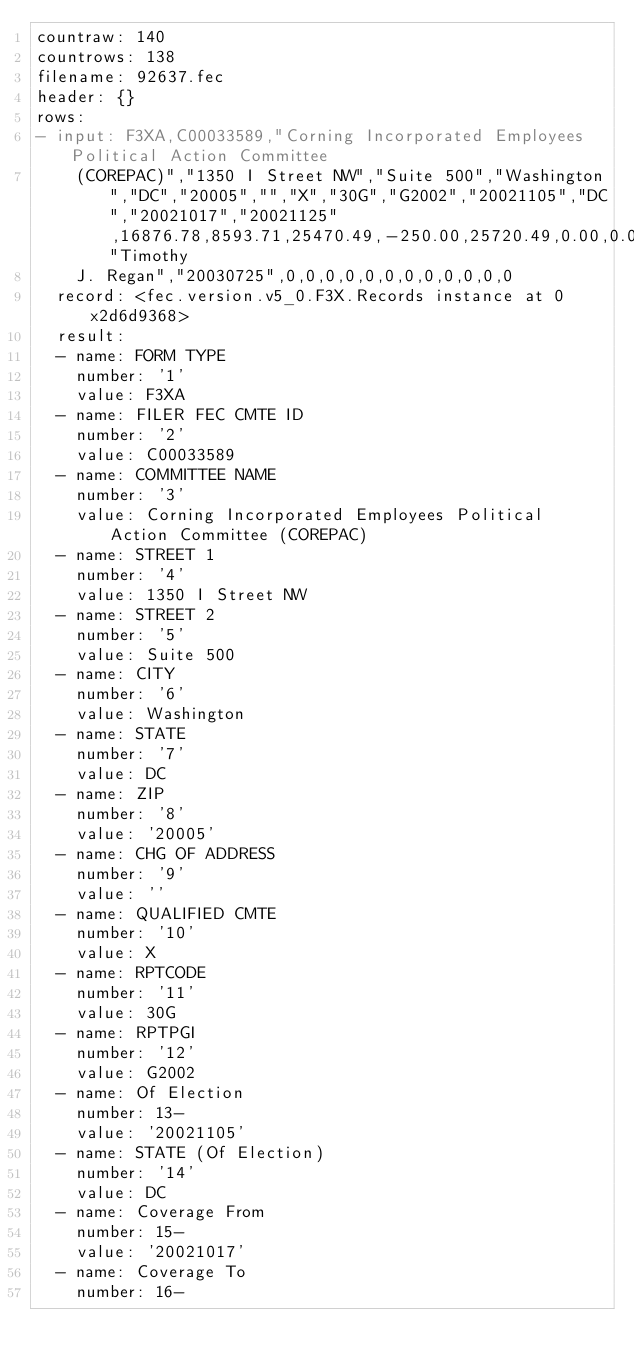<code> <loc_0><loc_0><loc_500><loc_500><_YAML_>countraw: 140
countrows: 138
filename: 92637.fec
header: {}
rows:
- input: F3XA,C00033589,"Corning Incorporated Employees Political Action Committee
    (COREPAC)","1350 I Street NW","Suite 500","Washington","DC","20005","","X","30G","G2002","20021105","DC","20021017","20021125",16876.78,8593.71,25470.49,-250.00,25720.49,0.00,0.00,7997.00,593.50,8590.50,0.00,0.00,8590.50,0.00,0.00,0.00,0.00,0.00,3.21,0.00,8593.71,8593.71,0.00,0.00,0.00,0.00,0.00,-250.00,0.00,0.00,0.00,0.00,0.00,0.00,0.00,0.00,0.00,-250.00,-250.00,8590.50,0.00,8590.50,0.00,0.00,0.00,60230.42,2002,93709.55,153939.97,128219.48,25720.49,93674.50,0.00,93674.50,0.00,0.00,93674.50,0.00,0.00,0.00,0.00,0.00,35.05,0.00,93709.55,93709.55,0.00,0.00,4954.15,4954.15,0.00,108120.33,0.00,0.00,0.00,0.00,25.00,0.00,0.00,25.00,15120.00,128219.48,128219.48,93674.50,25.00,93649.50,4954.15,0.00,4954.15,"Timothy
    J. Regan","20030725",0,0,0,0,0,0,0,0,0,0,0,0
  record: <fec.version.v5_0.F3X.Records instance at 0x2d6d9368>
  result:
  - name: FORM TYPE
    number: '1'
    value: F3XA
  - name: FILER FEC CMTE ID
    number: '2'
    value: C00033589
  - name: COMMITTEE NAME
    number: '3'
    value: Corning Incorporated Employees Political Action Committee (COREPAC)
  - name: STREET 1
    number: '4'
    value: 1350 I Street NW
  - name: STREET 2
    number: '5'
    value: Suite 500
  - name: CITY
    number: '6'
    value: Washington
  - name: STATE
    number: '7'
    value: DC
  - name: ZIP
    number: '8'
    value: '20005'
  - name: CHG OF ADDRESS
    number: '9'
    value: ''
  - name: QUALIFIED CMTE
    number: '10'
    value: X
  - name: RPTCODE
    number: '11'
    value: 30G
  - name: RPTPGI
    number: '12'
    value: G2002
  - name: Of Election
    number: 13-
    value: '20021105'
  - name: STATE (Of Election)
    number: '14'
    value: DC
  - name: Coverage From
    number: 15-
    value: '20021017'
  - name: Coverage To
    number: 16-</code> 